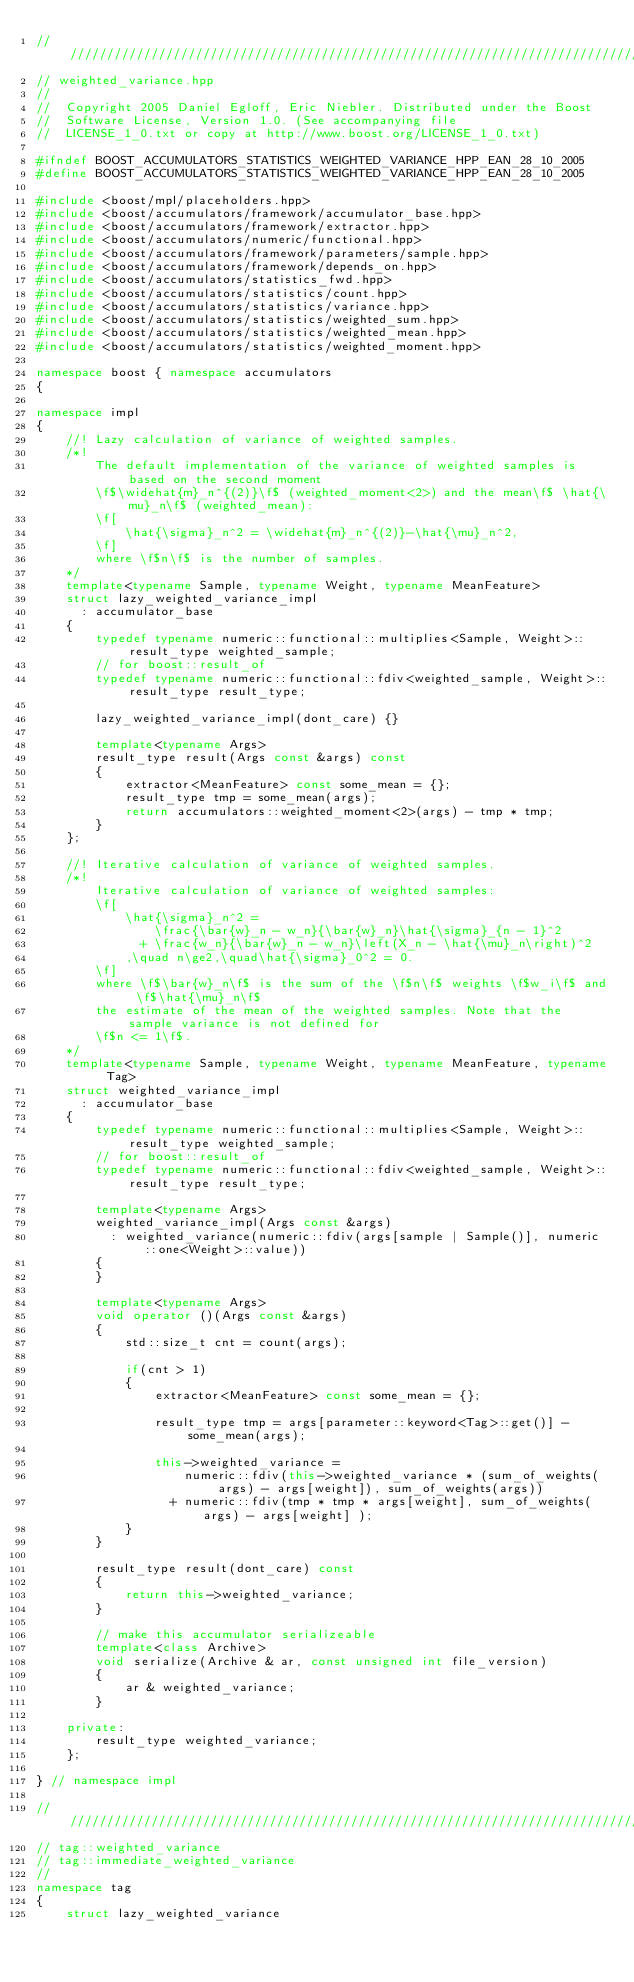<code> <loc_0><loc_0><loc_500><loc_500><_C++_>///////////////////////////////////////////////////////////////////////////////
// weighted_variance.hpp
//
//  Copyright 2005 Daniel Egloff, Eric Niebler. Distributed under the Boost
//  Software License, Version 1.0. (See accompanying file
//  LICENSE_1_0.txt or copy at http://www.boost.org/LICENSE_1_0.txt)

#ifndef BOOST_ACCUMULATORS_STATISTICS_WEIGHTED_VARIANCE_HPP_EAN_28_10_2005
#define BOOST_ACCUMULATORS_STATISTICS_WEIGHTED_VARIANCE_HPP_EAN_28_10_2005

#include <boost/mpl/placeholders.hpp>
#include <boost/accumulators/framework/accumulator_base.hpp>
#include <boost/accumulators/framework/extractor.hpp>
#include <boost/accumulators/numeric/functional.hpp>
#include <boost/accumulators/framework/parameters/sample.hpp>
#include <boost/accumulators/framework/depends_on.hpp>
#include <boost/accumulators/statistics_fwd.hpp>
#include <boost/accumulators/statistics/count.hpp>
#include <boost/accumulators/statistics/variance.hpp>
#include <boost/accumulators/statistics/weighted_sum.hpp>
#include <boost/accumulators/statistics/weighted_mean.hpp>
#include <boost/accumulators/statistics/weighted_moment.hpp>

namespace boost { namespace accumulators
{

namespace impl
{
    //! Lazy calculation of variance of weighted samples.
    /*!
        The default implementation of the variance of weighted samples is based on the second moment
        \f$\widehat{m}_n^{(2)}\f$ (weighted_moment<2>) and the mean\f$ \hat{\mu}_n\f$ (weighted_mean):
        \f[
            \hat{\sigma}_n^2 = \widehat{m}_n^{(2)}-\hat{\mu}_n^2,
        \f]
        where \f$n\f$ is the number of samples.
    */
    template<typename Sample, typename Weight, typename MeanFeature>
    struct lazy_weighted_variance_impl
      : accumulator_base
    {
        typedef typename numeric::functional::multiplies<Sample, Weight>::result_type weighted_sample;
        // for boost::result_of
        typedef typename numeric::functional::fdiv<weighted_sample, Weight>::result_type result_type;

        lazy_weighted_variance_impl(dont_care) {}

        template<typename Args>
        result_type result(Args const &args) const
        {
            extractor<MeanFeature> const some_mean = {};
            result_type tmp = some_mean(args);
            return accumulators::weighted_moment<2>(args) - tmp * tmp;
        }
    };

    //! Iterative calculation of variance of weighted samples.
    /*!
        Iterative calculation of variance of weighted samples:
        \f[
            \hat{\sigma}_n^2 =
                \frac{\bar{w}_n - w_n}{\bar{w}_n}\hat{\sigma}_{n - 1}^2
              + \frac{w_n}{\bar{w}_n - w_n}\left(X_n - \hat{\mu}_n\right)^2
            ,\quad n\ge2,\quad\hat{\sigma}_0^2 = 0.
        \f]
        where \f$\bar{w}_n\f$ is the sum of the \f$n\f$ weights \f$w_i\f$ and \f$\hat{\mu}_n\f$
        the estimate of the mean of the weighted samples. Note that the sample variance is not defined for
        \f$n <= 1\f$.
    */
    template<typename Sample, typename Weight, typename MeanFeature, typename Tag>
    struct weighted_variance_impl
      : accumulator_base
    {
        typedef typename numeric::functional::multiplies<Sample, Weight>::result_type weighted_sample;
        // for boost::result_of
        typedef typename numeric::functional::fdiv<weighted_sample, Weight>::result_type result_type;

        template<typename Args>
        weighted_variance_impl(Args const &args)
          : weighted_variance(numeric::fdiv(args[sample | Sample()], numeric::one<Weight>::value))
        {
        }

        template<typename Args>
        void operator ()(Args const &args)
        {
            std::size_t cnt = count(args);

            if(cnt > 1)
            {
                extractor<MeanFeature> const some_mean = {};

                result_type tmp = args[parameter::keyword<Tag>::get()] - some_mean(args);

                this->weighted_variance =
                    numeric::fdiv(this->weighted_variance * (sum_of_weights(args) - args[weight]), sum_of_weights(args))
                  + numeric::fdiv(tmp * tmp * args[weight], sum_of_weights(args) - args[weight] );
            }
        }

        result_type result(dont_care) const
        {
            return this->weighted_variance;
        }

        // make this accumulator serializeable
        template<class Archive>
        void serialize(Archive & ar, const unsigned int file_version)
        {
            ar & weighted_variance;
        }

    private:
        result_type weighted_variance;
    };

} // namespace impl

///////////////////////////////////////////////////////////////////////////////
// tag::weighted_variance
// tag::immediate_weighted_variance
//
namespace tag
{
    struct lazy_weighted_variance</code> 